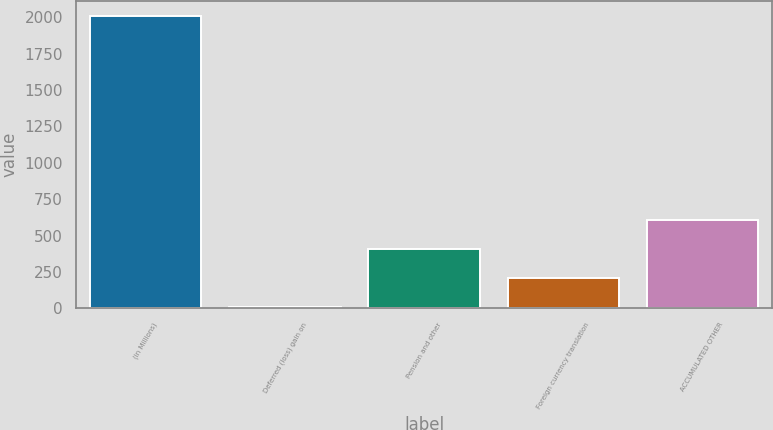Convert chart to OTSL. <chart><loc_0><loc_0><loc_500><loc_500><bar_chart><fcel>(in Millions)<fcel>Deferred (loss) gain on<fcel>Pension and other<fcel>Foreign currency translation<fcel>ACCUMULATED OTHER<nl><fcel>2011<fcel>7.2<fcel>407.96<fcel>207.58<fcel>608.34<nl></chart> 